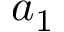Convert formula to latex. <formula><loc_0><loc_0><loc_500><loc_500>a _ { 1 }</formula> 